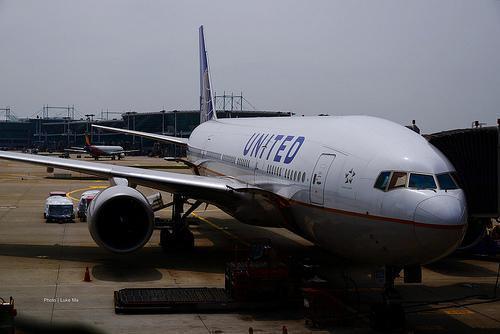How many planes?
Give a very brief answer. 2. 